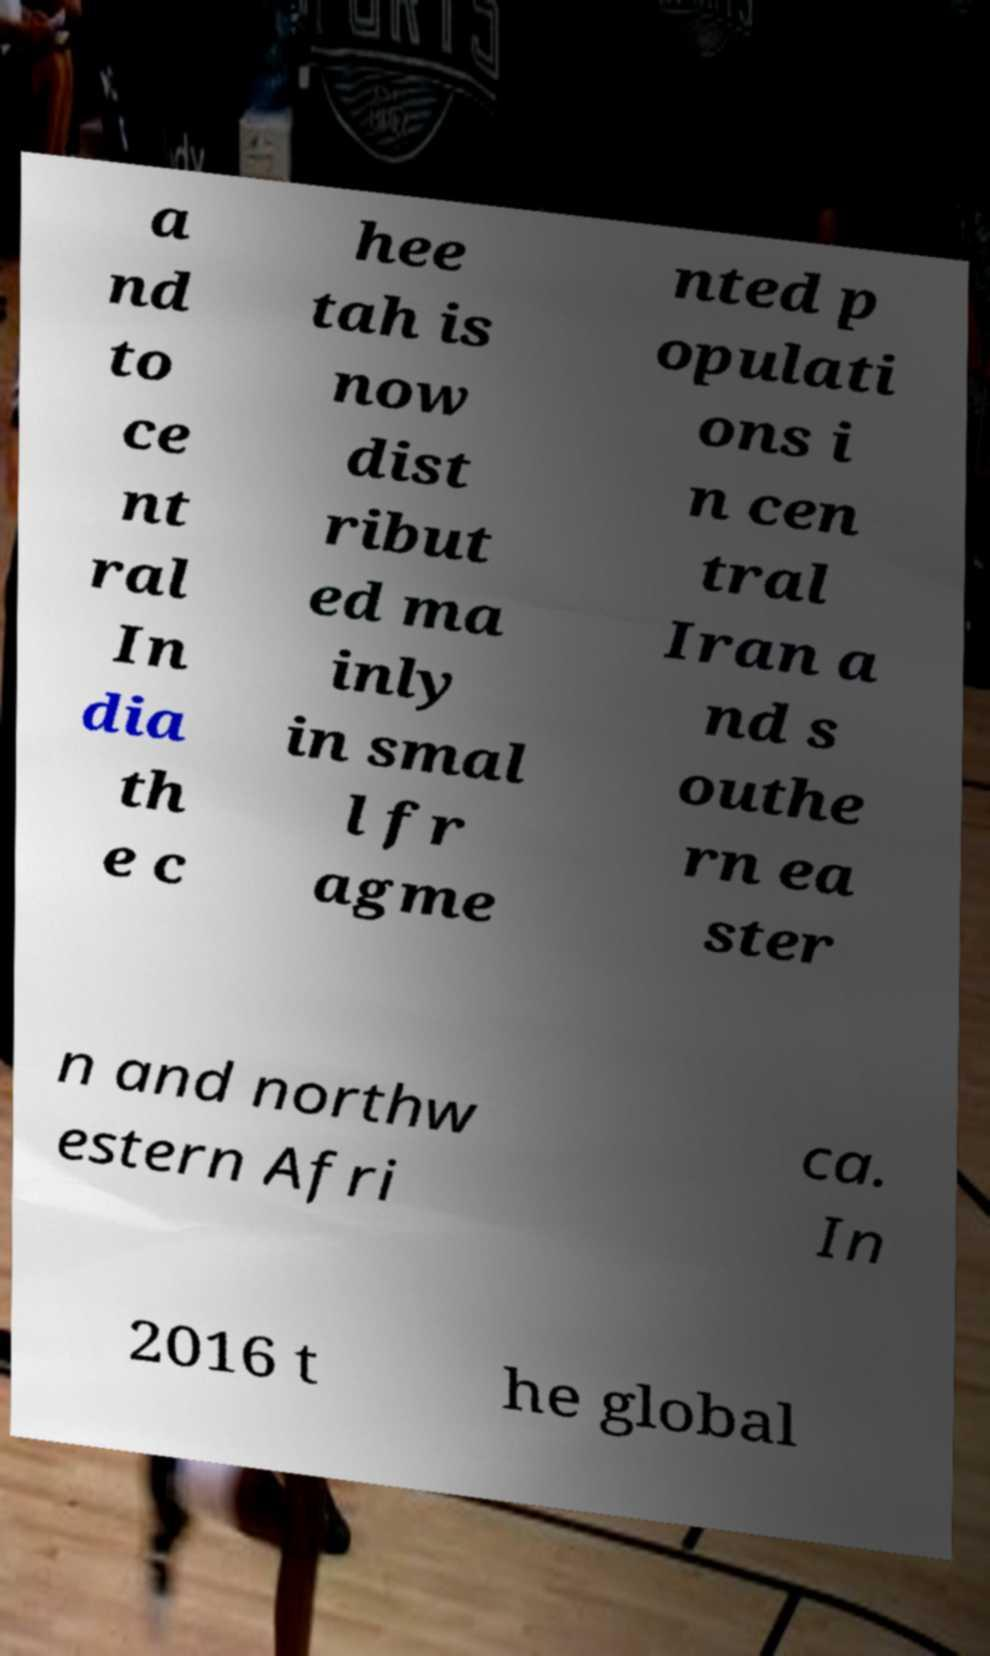Please read and relay the text visible in this image. What does it say? a nd to ce nt ral In dia th e c hee tah is now dist ribut ed ma inly in smal l fr agme nted p opulati ons i n cen tral Iran a nd s outhe rn ea ster n and northw estern Afri ca. In 2016 t he global 